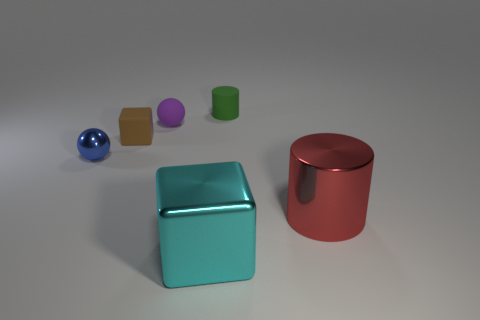Add 2 tiny green shiny blocks. How many objects exist? 8 Subtract all blocks. How many objects are left? 4 Subtract 1 brown blocks. How many objects are left? 5 Subtract all cylinders. Subtract all metallic cubes. How many objects are left? 3 Add 1 rubber things. How many rubber things are left? 4 Add 4 large blue spheres. How many large blue spheres exist? 4 